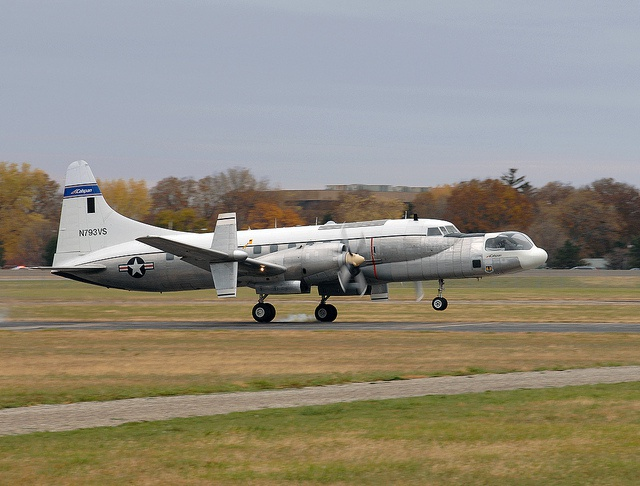Describe the objects in this image and their specific colors. I can see a airplane in darkgray, lightgray, black, and gray tones in this image. 